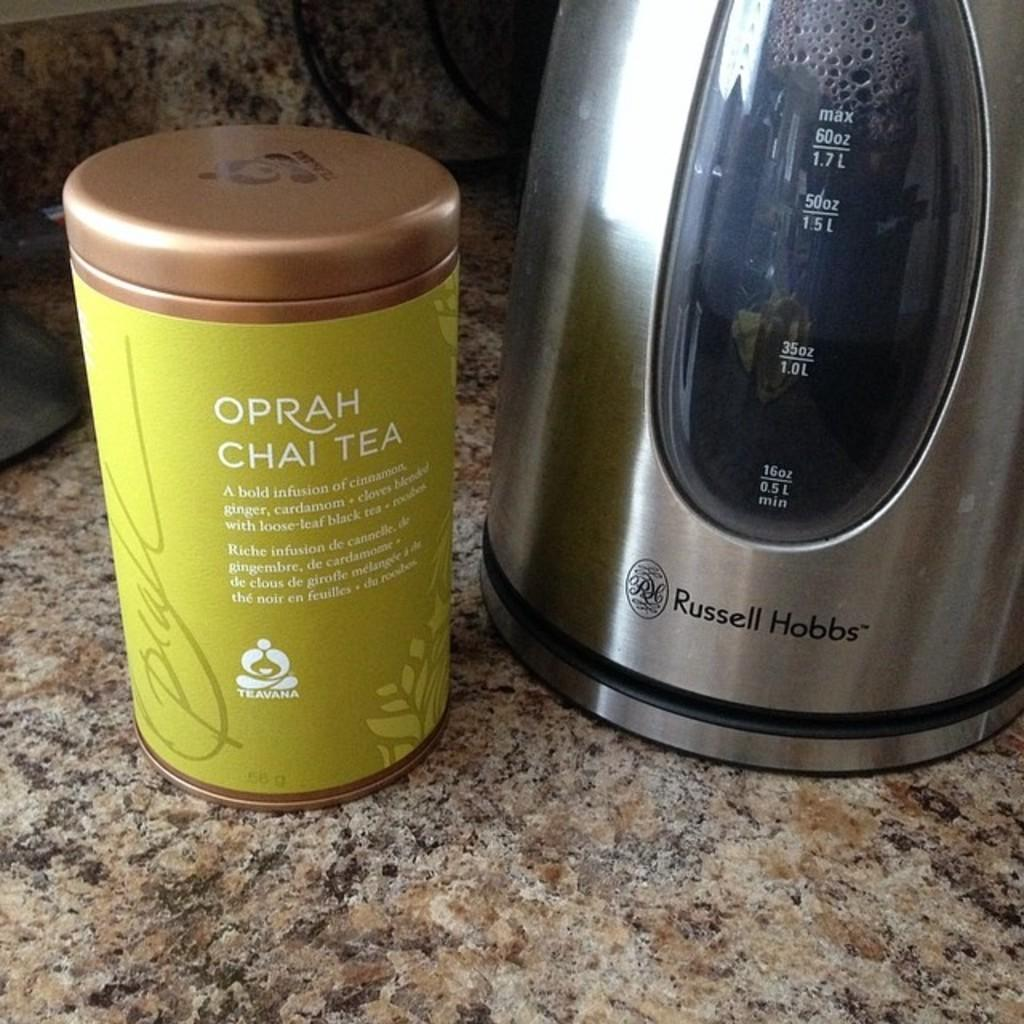<image>
Share a concise interpretation of the image provided. A lime green canister of Oprah Chai Tea sits on a granite counter top next to an electric kettle. 